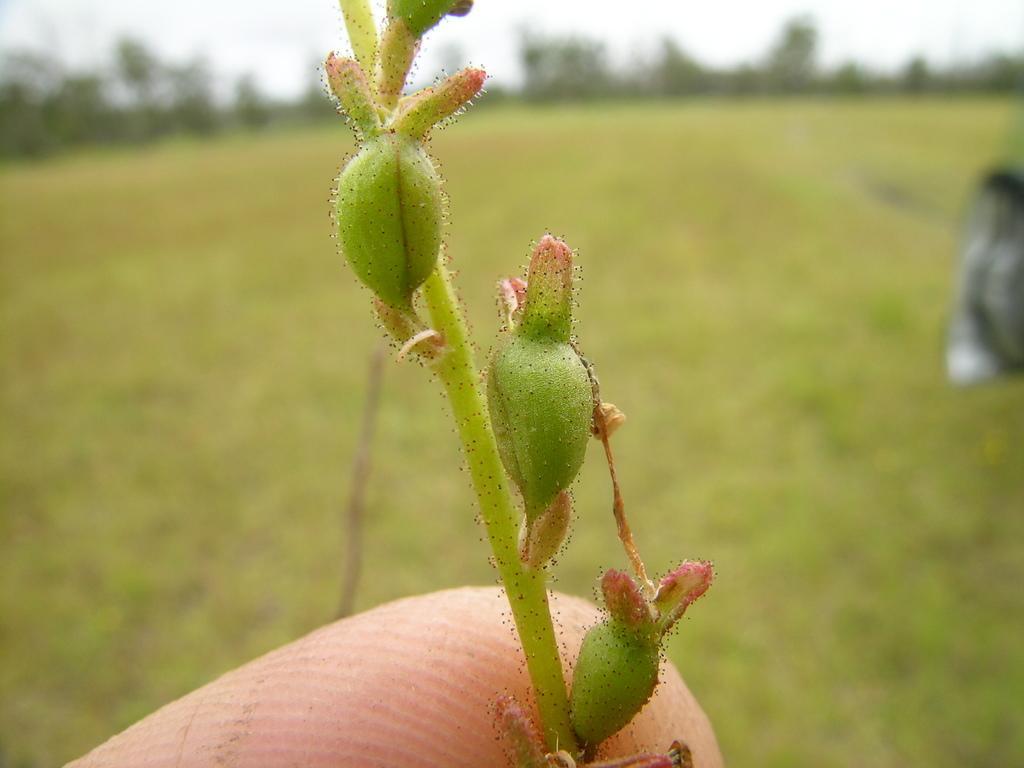Could you give a brief overview of what you see in this image? In this image we can see a plant stem and persons finger. At the bottom of the image there is grass. In the background of the image there are trees. 